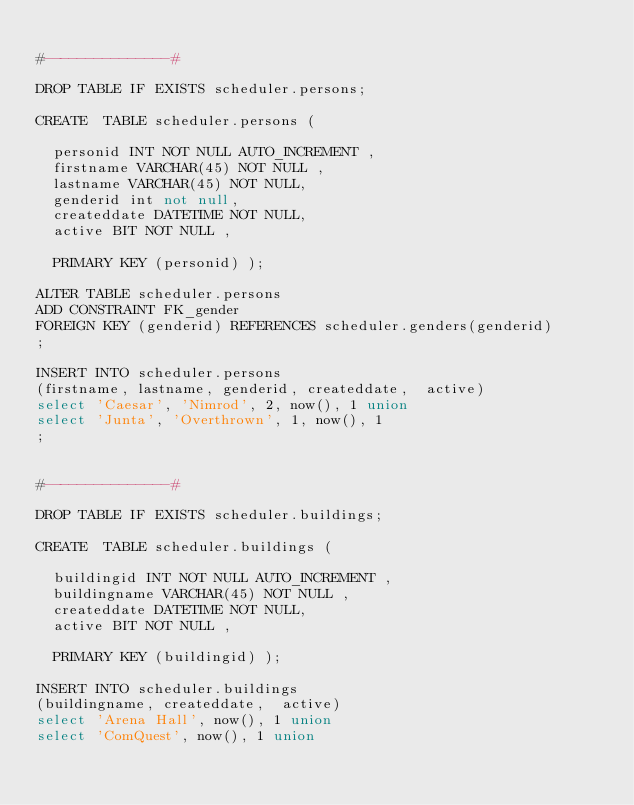Convert code to text. <code><loc_0><loc_0><loc_500><loc_500><_SQL_>
#---------------#

DROP TABLE IF EXISTS scheduler.persons;

CREATE  TABLE scheduler.persons (

  personid INT NOT NULL AUTO_INCREMENT ,
  firstname VARCHAR(45) NOT NULL ,
  lastname VARCHAR(45) NOT NULL,
  genderid int not null,
  createddate DATETIME NOT NULL,
  active BIT NOT NULL ,

  PRIMARY KEY (personid) );

ALTER TABLE scheduler.persons 
ADD CONSTRAINT FK_gender
FOREIGN KEY (genderid) REFERENCES scheduler.genders(genderid) 
;

INSERT INTO scheduler.persons
(firstname, lastname, genderid, createddate,  active)
select 'Caesar', 'Nimrod', 2, now(), 1 union
select 'Junta', 'Overthrown', 1, now(), 1 
;


#---------------#

DROP TABLE IF EXISTS scheduler.buildings;

CREATE  TABLE scheduler.buildings (

  buildingid INT NOT NULL AUTO_INCREMENT ,
  buildingname VARCHAR(45) NOT NULL ,
  createddate DATETIME NOT NULL,
  active BIT NOT NULL ,

  PRIMARY KEY (buildingid) );

INSERT INTO scheduler.buildings
(buildingname, createddate,  active)
select 'Arena Hall', now(), 1 union
select 'ComQuest', now(), 1 union</code> 